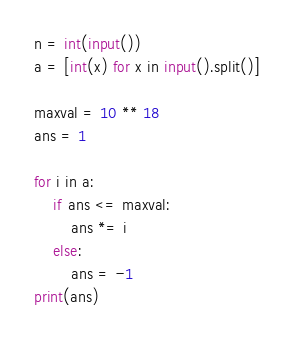Convert code to text. <code><loc_0><loc_0><loc_500><loc_500><_Python_>n = int(input())
a = [int(x) for x in input().split()]

maxval = 10 ** 18
ans = 1

for i in a:
    if ans <= maxval:
        ans *= i
    else:
        ans = -1
print(ans)
</code> 